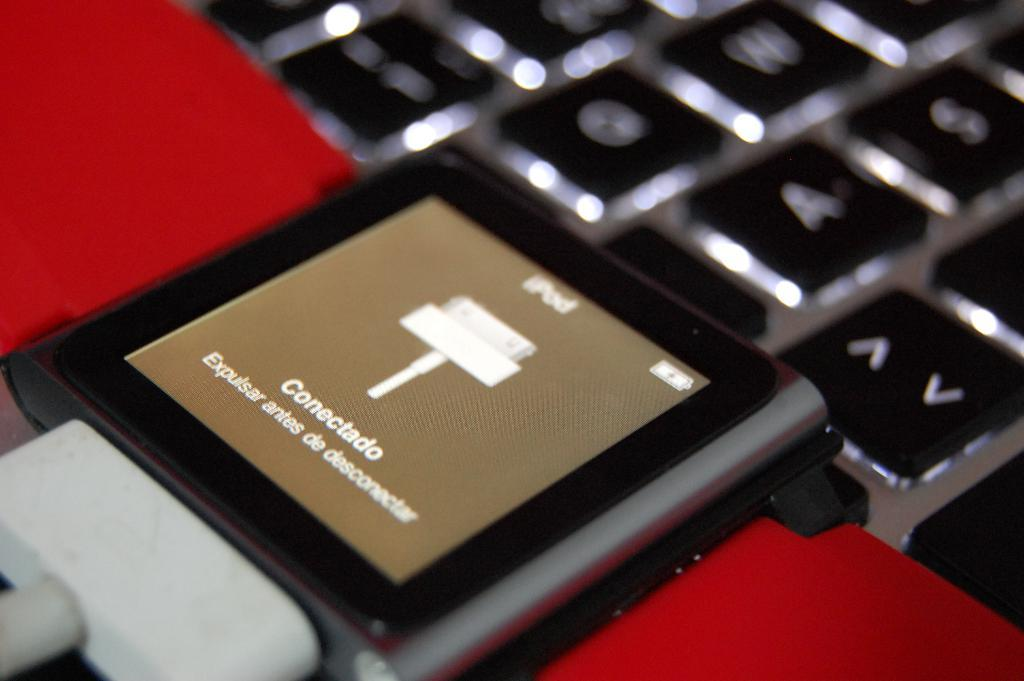<image>
Offer a succinct explanation of the picture presented. a cord plugged in to an ipod that has the screen on that says 'conectado expulsar antes de desconnectar' 